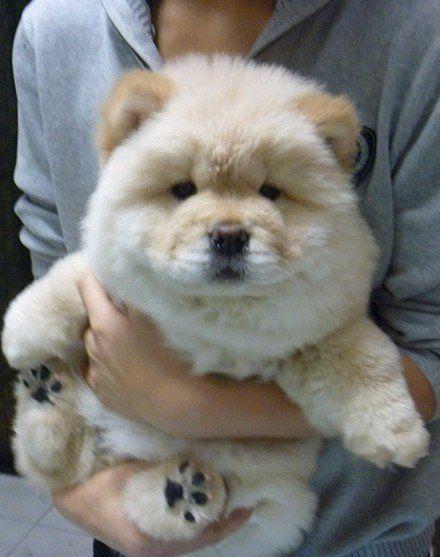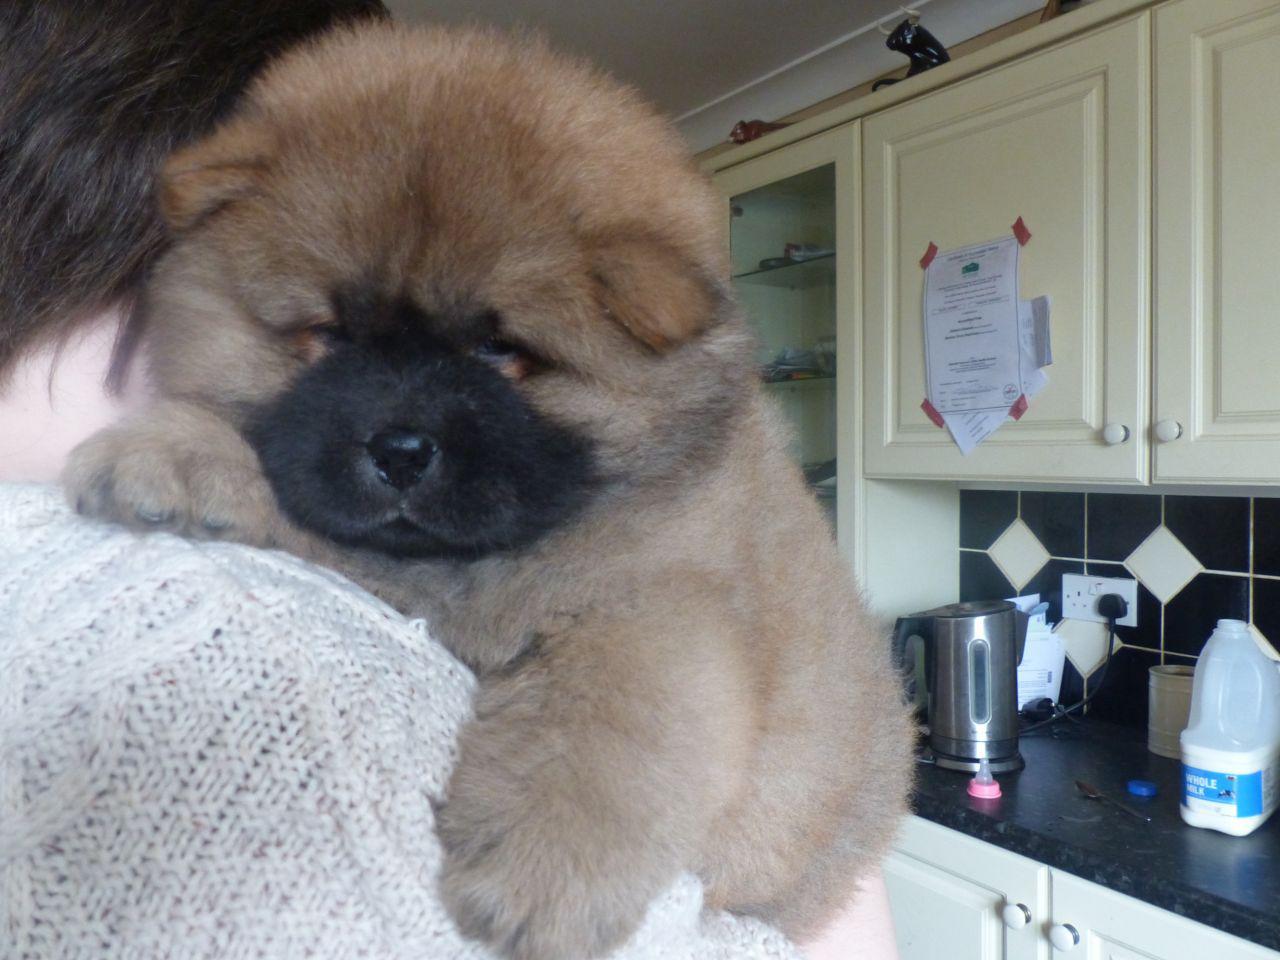The first image is the image on the left, the second image is the image on the right. Considering the images on both sides, is "THere are exactly two dogs in the image on the left." valid? Answer yes or no. No. The first image is the image on the left, the second image is the image on the right. Assess this claim about the two images: "Exactly four dogs are shown in groups of two.". Correct or not? Answer yes or no. No. 